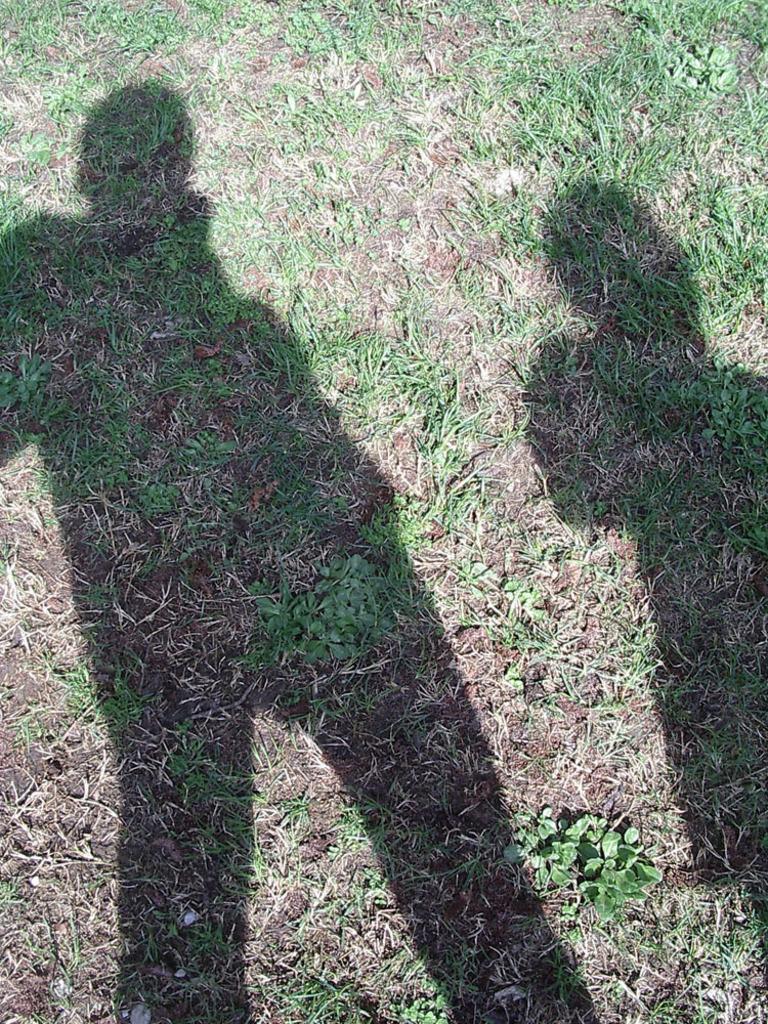Can you describe this image briefly? Here in this picture we can see the ground is fully covered with grass and we can see shadows of persons present on ground. 